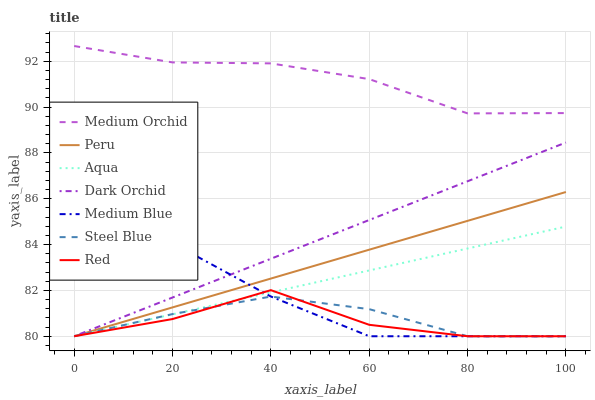Does Red have the minimum area under the curve?
Answer yes or no. Yes. Does Medium Orchid have the maximum area under the curve?
Answer yes or no. Yes. Does Medium Blue have the minimum area under the curve?
Answer yes or no. No. Does Medium Blue have the maximum area under the curve?
Answer yes or no. No. Is Dark Orchid the smoothest?
Answer yes or no. Yes. Is Medium Blue the roughest?
Answer yes or no. Yes. Is Medium Orchid the smoothest?
Answer yes or no. No. Is Medium Orchid the roughest?
Answer yes or no. No. Does Aqua have the lowest value?
Answer yes or no. Yes. Does Medium Orchid have the lowest value?
Answer yes or no. No. Does Medium Orchid have the highest value?
Answer yes or no. Yes. Does Medium Blue have the highest value?
Answer yes or no. No. Is Aqua less than Medium Orchid?
Answer yes or no. Yes. Is Medium Orchid greater than Peru?
Answer yes or no. Yes. Does Peru intersect Red?
Answer yes or no. Yes. Is Peru less than Red?
Answer yes or no. No. Is Peru greater than Red?
Answer yes or no. No. Does Aqua intersect Medium Orchid?
Answer yes or no. No. 